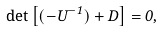Convert formula to latex. <formula><loc_0><loc_0><loc_500><loc_500>\det \left [ ( - U ^ { - 1 } ) + D \right ] = 0 ,</formula> 